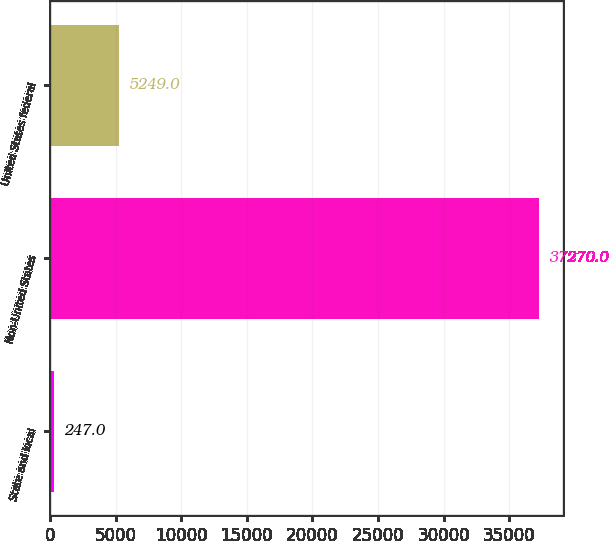Convert chart. <chart><loc_0><loc_0><loc_500><loc_500><bar_chart><fcel>State and local<fcel>Non-United States<fcel>United States federal<nl><fcel>247<fcel>37270<fcel>5249<nl></chart> 